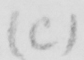Can you read and transcribe this handwriting? ( C ) 